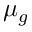Convert formula to latex. <formula><loc_0><loc_0><loc_500><loc_500>\mu _ { g }</formula> 